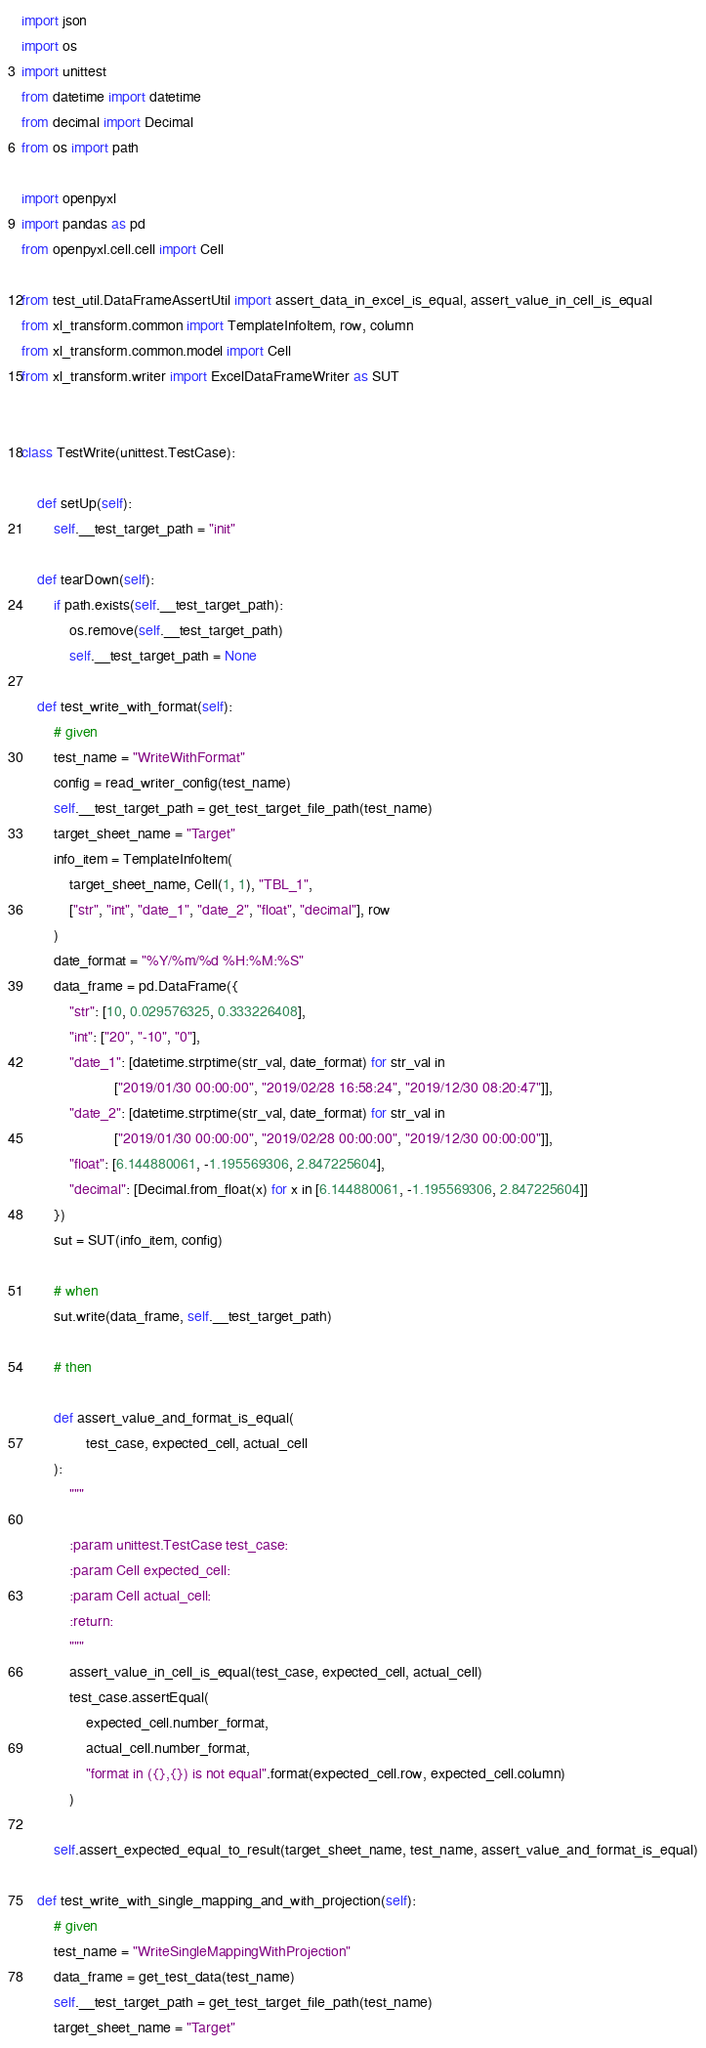Convert code to text. <code><loc_0><loc_0><loc_500><loc_500><_Python_>import json
import os
import unittest
from datetime import datetime
from decimal import Decimal
from os import path

import openpyxl
import pandas as pd
from openpyxl.cell.cell import Cell

from test_util.DataFrameAssertUtil import assert_data_in_excel_is_equal, assert_value_in_cell_is_equal
from xl_transform.common import TemplateInfoItem, row, column
from xl_transform.common.model import Cell
from xl_transform.writer import ExcelDataFrameWriter as SUT


class TestWrite(unittest.TestCase):

    def setUp(self):
        self.__test_target_path = "init"

    def tearDown(self):
        if path.exists(self.__test_target_path):
            os.remove(self.__test_target_path)
            self.__test_target_path = None

    def test_write_with_format(self):
        # given
        test_name = "WriteWithFormat"
        config = read_writer_config(test_name)
        self.__test_target_path = get_test_target_file_path(test_name)
        target_sheet_name = "Target"
        info_item = TemplateInfoItem(
            target_sheet_name, Cell(1, 1), "TBL_1",
            ["str", "int", "date_1", "date_2", "float", "decimal"], row
        )
        date_format = "%Y/%m/%d %H:%M:%S"
        data_frame = pd.DataFrame({
            "str": [10, 0.029576325, 0.333226408],
            "int": ["20", "-10", "0"],
            "date_1": [datetime.strptime(str_val, date_format) for str_val in
                       ["2019/01/30 00:00:00", "2019/02/28 16:58:24", "2019/12/30 08:20:47"]],
            "date_2": [datetime.strptime(str_val, date_format) for str_val in
                       ["2019/01/30 00:00:00", "2019/02/28 00:00:00", "2019/12/30 00:00:00"]],
            "float": [6.144880061, -1.195569306, 2.847225604],
            "decimal": [Decimal.from_float(x) for x in [6.144880061, -1.195569306, 2.847225604]]
        })
        sut = SUT(info_item, config)

        # when
        sut.write(data_frame, self.__test_target_path)

        # then

        def assert_value_and_format_is_equal(
                test_case, expected_cell, actual_cell
        ):
            """

            :param unittest.TestCase test_case:
            :param Cell expected_cell:
            :param Cell actual_cell:
            :return:
            """
            assert_value_in_cell_is_equal(test_case, expected_cell, actual_cell)
            test_case.assertEqual(
                expected_cell.number_format,
                actual_cell.number_format,
                "format in ({},{}) is not equal".format(expected_cell.row, expected_cell.column)
            )

        self.assert_expected_equal_to_result(target_sheet_name, test_name, assert_value_and_format_is_equal)

    def test_write_with_single_mapping_and_with_projection(self):
        # given
        test_name = "WriteSingleMappingWithProjection"
        data_frame = get_test_data(test_name)
        self.__test_target_path = get_test_target_file_path(test_name)
        target_sheet_name = "Target"</code> 